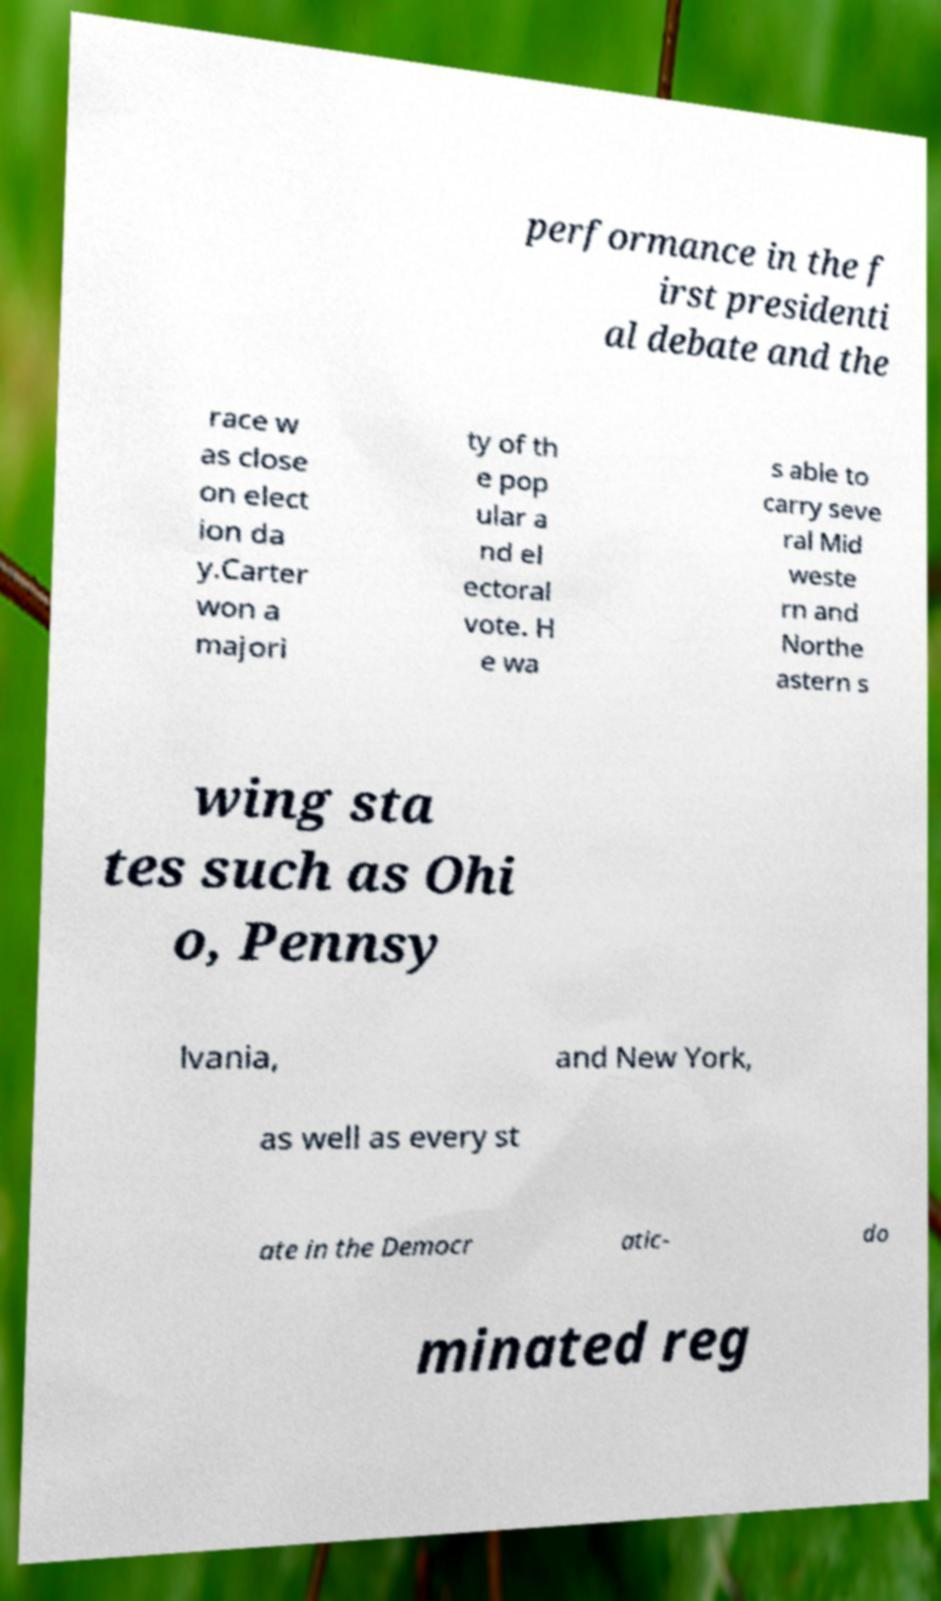I need the written content from this picture converted into text. Can you do that? performance in the f irst presidenti al debate and the race w as close on elect ion da y.Carter won a majori ty of th e pop ular a nd el ectoral vote. H e wa s able to carry seve ral Mid weste rn and Northe astern s wing sta tes such as Ohi o, Pennsy lvania, and New York, as well as every st ate in the Democr atic- do minated reg 